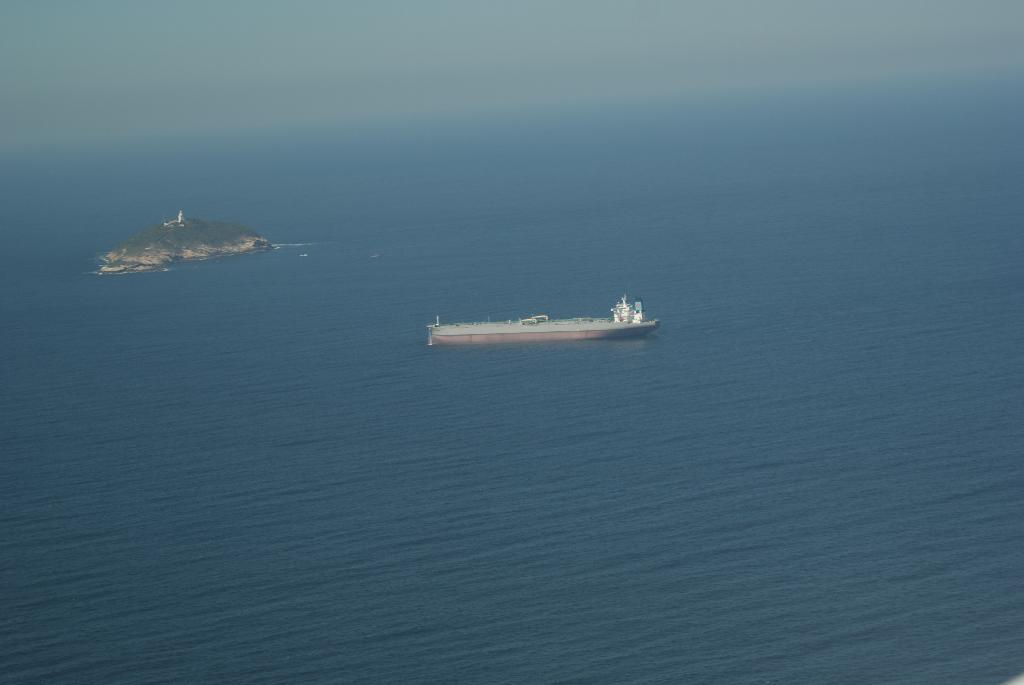What is the main subject of the image? The main subject of the image is a ship. Where is the ship located in the image? The ship is on the water. What else can be seen in the image besides the ship? There is land visible behind the ship, and the sky is visible in the image. What type of butter is being used to grease the cannon in the image? There is no cannon present in the image, and therefore no butter or greasing activity can be observed. 